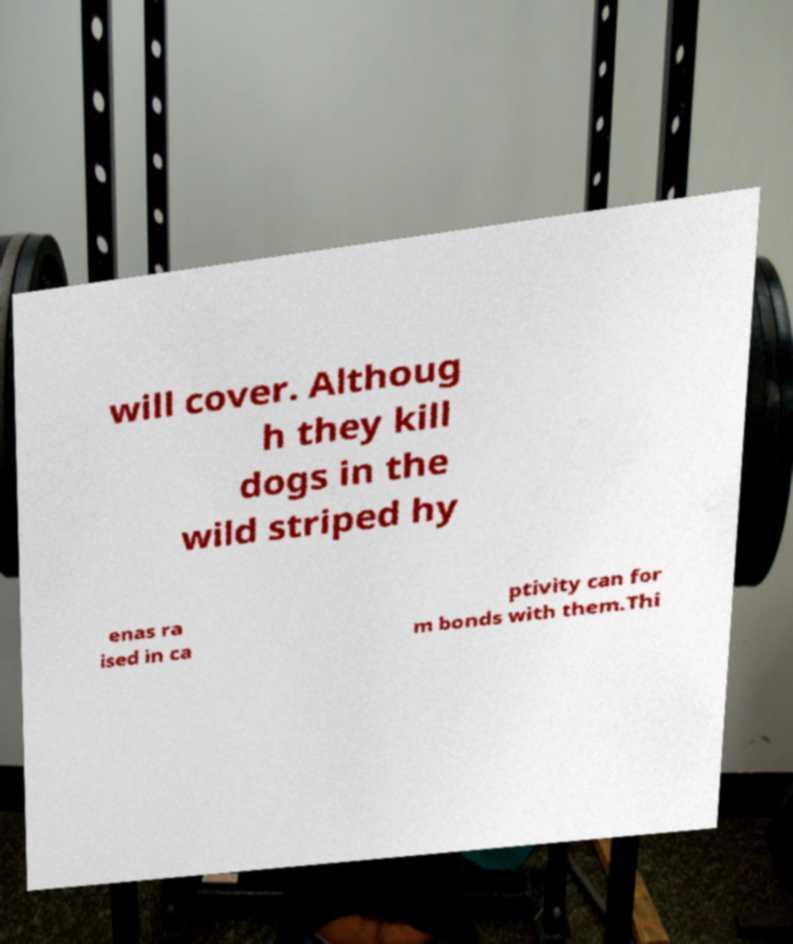I need the written content from this picture converted into text. Can you do that? will cover. Althoug h they kill dogs in the wild striped hy enas ra ised in ca ptivity can for m bonds with them.Thi 